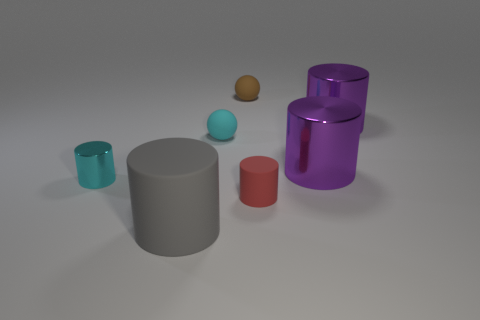Subtract 3 cylinders. How many cylinders are left? 2 Subtract all cyan cylinders. How many cylinders are left? 4 Subtract all tiny cyan cylinders. How many cylinders are left? 4 Subtract all red cylinders. Subtract all red blocks. How many cylinders are left? 4 Add 1 small cyan metallic things. How many objects exist? 8 Subtract all balls. How many objects are left? 5 Add 6 small red rubber cylinders. How many small red rubber cylinders exist? 7 Subtract 0 red cubes. How many objects are left? 7 Subtract all large things. Subtract all red matte cylinders. How many objects are left? 3 Add 7 red things. How many red things are left? 8 